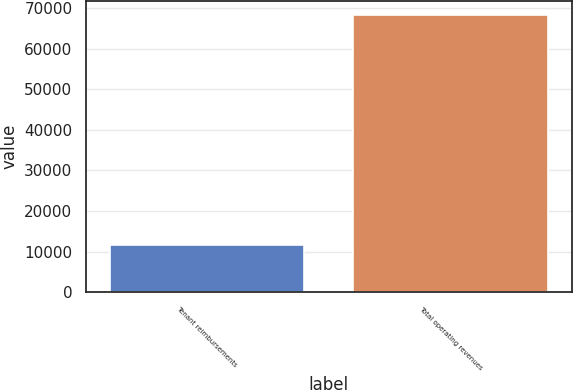Convert chart. <chart><loc_0><loc_0><loc_500><loc_500><bar_chart><fcel>Tenant reimbursements<fcel>Total operating revenues<nl><fcel>11735<fcel>68317<nl></chart> 